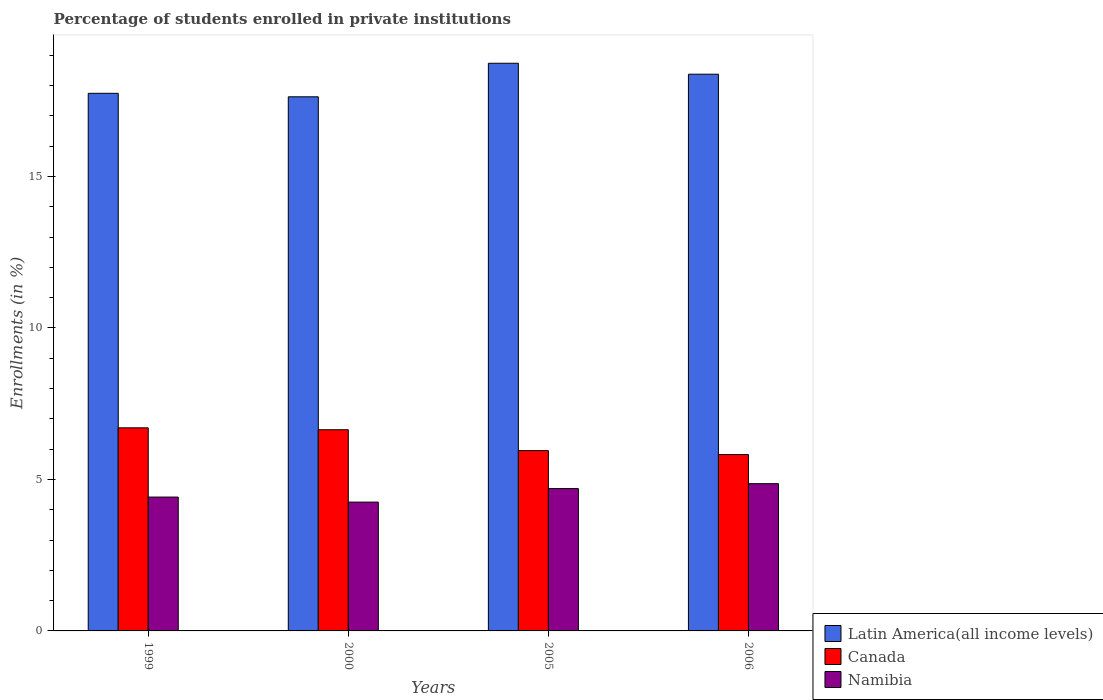How many groups of bars are there?
Give a very brief answer. 4. Are the number of bars per tick equal to the number of legend labels?
Give a very brief answer. Yes. How many bars are there on the 3rd tick from the right?
Provide a short and direct response. 3. What is the label of the 1st group of bars from the left?
Keep it short and to the point. 1999. What is the percentage of trained teachers in Canada in 1999?
Make the answer very short. 6.7. Across all years, what is the maximum percentage of trained teachers in Latin America(all income levels)?
Offer a very short reply. 18.73. Across all years, what is the minimum percentage of trained teachers in Namibia?
Provide a short and direct response. 4.25. What is the total percentage of trained teachers in Latin America(all income levels) in the graph?
Your response must be concise. 72.48. What is the difference between the percentage of trained teachers in Canada in 2000 and that in 2005?
Make the answer very short. 0.69. What is the difference between the percentage of trained teachers in Namibia in 2005 and the percentage of trained teachers in Latin America(all income levels) in 2006?
Provide a short and direct response. -13.68. What is the average percentage of trained teachers in Namibia per year?
Offer a terse response. 4.56. In the year 2000, what is the difference between the percentage of trained teachers in Namibia and percentage of trained teachers in Latin America(all income levels)?
Provide a succinct answer. -13.38. What is the ratio of the percentage of trained teachers in Canada in 1999 to that in 2006?
Keep it short and to the point. 1.15. Is the percentage of trained teachers in Latin America(all income levels) in 1999 less than that in 2006?
Your answer should be very brief. Yes. Is the difference between the percentage of trained teachers in Namibia in 1999 and 2000 greater than the difference between the percentage of trained teachers in Latin America(all income levels) in 1999 and 2000?
Your response must be concise. Yes. What is the difference between the highest and the second highest percentage of trained teachers in Canada?
Offer a very short reply. 0.06. What is the difference between the highest and the lowest percentage of trained teachers in Canada?
Your response must be concise. 0.88. In how many years, is the percentage of trained teachers in Namibia greater than the average percentage of trained teachers in Namibia taken over all years?
Keep it short and to the point. 2. What does the 3rd bar from the left in 2000 represents?
Provide a short and direct response. Namibia. What does the 3rd bar from the right in 2005 represents?
Your response must be concise. Latin America(all income levels). How many bars are there?
Provide a short and direct response. 12. Are all the bars in the graph horizontal?
Keep it short and to the point. No. What is the difference between two consecutive major ticks on the Y-axis?
Offer a very short reply. 5. Does the graph contain any zero values?
Your answer should be very brief. No. Does the graph contain grids?
Give a very brief answer. No. What is the title of the graph?
Your answer should be very brief. Percentage of students enrolled in private institutions. What is the label or title of the Y-axis?
Provide a succinct answer. Enrollments (in %). What is the Enrollments (in %) in Latin America(all income levels) in 1999?
Your answer should be compact. 17.74. What is the Enrollments (in %) in Canada in 1999?
Keep it short and to the point. 6.7. What is the Enrollments (in %) of Namibia in 1999?
Give a very brief answer. 4.42. What is the Enrollments (in %) in Latin America(all income levels) in 2000?
Provide a succinct answer. 17.63. What is the Enrollments (in %) in Canada in 2000?
Make the answer very short. 6.64. What is the Enrollments (in %) in Namibia in 2000?
Make the answer very short. 4.25. What is the Enrollments (in %) in Latin America(all income levels) in 2005?
Your answer should be compact. 18.73. What is the Enrollments (in %) of Canada in 2005?
Provide a succinct answer. 5.95. What is the Enrollments (in %) in Namibia in 2005?
Your response must be concise. 4.7. What is the Enrollments (in %) in Latin America(all income levels) in 2006?
Your response must be concise. 18.37. What is the Enrollments (in %) of Canada in 2006?
Ensure brevity in your answer.  5.82. What is the Enrollments (in %) in Namibia in 2006?
Provide a succinct answer. 4.86. Across all years, what is the maximum Enrollments (in %) of Latin America(all income levels)?
Keep it short and to the point. 18.73. Across all years, what is the maximum Enrollments (in %) of Canada?
Ensure brevity in your answer.  6.7. Across all years, what is the maximum Enrollments (in %) in Namibia?
Offer a terse response. 4.86. Across all years, what is the minimum Enrollments (in %) of Latin America(all income levels)?
Keep it short and to the point. 17.63. Across all years, what is the minimum Enrollments (in %) of Canada?
Ensure brevity in your answer.  5.82. Across all years, what is the minimum Enrollments (in %) in Namibia?
Keep it short and to the point. 4.25. What is the total Enrollments (in %) of Latin America(all income levels) in the graph?
Your answer should be very brief. 72.48. What is the total Enrollments (in %) in Canada in the graph?
Offer a terse response. 25.11. What is the total Enrollments (in %) of Namibia in the graph?
Offer a very short reply. 18.23. What is the difference between the Enrollments (in %) of Latin America(all income levels) in 1999 and that in 2000?
Make the answer very short. 0.11. What is the difference between the Enrollments (in %) in Canada in 1999 and that in 2000?
Provide a succinct answer. 0.06. What is the difference between the Enrollments (in %) in Namibia in 1999 and that in 2000?
Keep it short and to the point. 0.17. What is the difference between the Enrollments (in %) in Latin America(all income levels) in 1999 and that in 2005?
Your answer should be very brief. -0.99. What is the difference between the Enrollments (in %) in Canada in 1999 and that in 2005?
Offer a very short reply. 0.75. What is the difference between the Enrollments (in %) in Namibia in 1999 and that in 2005?
Give a very brief answer. -0.28. What is the difference between the Enrollments (in %) of Latin America(all income levels) in 1999 and that in 2006?
Offer a terse response. -0.63. What is the difference between the Enrollments (in %) of Canada in 1999 and that in 2006?
Offer a terse response. 0.88. What is the difference between the Enrollments (in %) in Namibia in 1999 and that in 2006?
Your answer should be very brief. -0.44. What is the difference between the Enrollments (in %) of Latin America(all income levels) in 2000 and that in 2005?
Keep it short and to the point. -1.11. What is the difference between the Enrollments (in %) of Canada in 2000 and that in 2005?
Your response must be concise. 0.69. What is the difference between the Enrollments (in %) in Namibia in 2000 and that in 2005?
Your answer should be very brief. -0.45. What is the difference between the Enrollments (in %) of Latin America(all income levels) in 2000 and that in 2006?
Provide a succinct answer. -0.75. What is the difference between the Enrollments (in %) of Canada in 2000 and that in 2006?
Your answer should be compact. 0.82. What is the difference between the Enrollments (in %) in Namibia in 2000 and that in 2006?
Ensure brevity in your answer.  -0.61. What is the difference between the Enrollments (in %) of Latin America(all income levels) in 2005 and that in 2006?
Offer a very short reply. 0.36. What is the difference between the Enrollments (in %) in Canada in 2005 and that in 2006?
Make the answer very short. 0.13. What is the difference between the Enrollments (in %) of Namibia in 2005 and that in 2006?
Your answer should be very brief. -0.16. What is the difference between the Enrollments (in %) of Latin America(all income levels) in 1999 and the Enrollments (in %) of Canada in 2000?
Your answer should be very brief. 11.1. What is the difference between the Enrollments (in %) of Latin America(all income levels) in 1999 and the Enrollments (in %) of Namibia in 2000?
Provide a short and direct response. 13.49. What is the difference between the Enrollments (in %) in Canada in 1999 and the Enrollments (in %) in Namibia in 2000?
Offer a very short reply. 2.45. What is the difference between the Enrollments (in %) of Latin America(all income levels) in 1999 and the Enrollments (in %) of Canada in 2005?
Provide a short and direct response. 11.79. What is the difference between the Enrollments (in %) in Latin America(all income levels) in 1999 and the Enrollments (in %) in Namibia in 2005?
Ensure brevity in your answer.  13.04. What is the difference between the Enrollments (in %) of Canada in 1999 and the Enrollments (in %) of Namibia in 2005?
Provide a short and direct response. 2. What is the difference between the Enrollments (in %) in Latin America(all income levels) in 1999 and the Enrollments (in %) in Canada in 2006?
Ensure brevity in your answer.  11.92. What is the difference between the Enrollments (in %) of Latin America(all income levels) in 1999 and the Enrollments (in %) of Namibia in 2006?
Ensure brevity in your answer.  12.88. What is the difference between the Enrollments (in %) in Canada in 1999 and the Enrollments (in %) in Namibia in 2006?
Offer a very short reply. 1.84. What is the difference between the Enrollments (in %) of Latin America(all income levels) in 2000 and the Enrollments (in %) of Canada in 2005?
Keep it short and to the point. 11.68. What is the difference between the Enrollments (in %) of Latin America(all income levels) in 2000 and the Enrollments (in %) of Namibia in 2005?
Your response must be concise. 12.93. What is the difference between the Enrollments (in %) in Canada in 2000 and the Enrollments (in %) in Namibia in 2005?
Offer a terse response. 1.94. What is the difference between the Enrollments (in %) of Latin America(all income levels) in 2000 and the Enrollments (in %) of Canada in 2006?
Keep it short and to the point. 11.81. What is the difference between the Enrollments (in %) of Latin America(all income levels) in 2000 and the Enrollments (in %) of Namibia in 2006?
Make the answer very short. 12.77. What is the difference between the Enrollments (in %) of Canada in 2000 and the Enrollments (in %) of Namibia in 2006?
Ensure brevity in your answer.  1.78. What is the difference between the Enrollments (in %) in Latin America(all income levels) in 2005 and the Enrollments (in %) in Canada in 2006?
Your response must be concise. 12.91. What is the difference between the Enrollments (in %) of Latin America(all income levels) in 2005 and the Enrollments (in %) of Namibia in 2006?
Provide a succinct answer. 13.88. What is the difference between the Enrollments (in %) in Canada in 2005 and the Enrollments (in %) in Namibia in 2006?
Your answer should be compact. 1.09. What is the average Enrollments (in %) of Latin America(all income levels) per year?
Keep it short and to the point. 18.12. What is the average Enrollments (in %) in Canada per year?
Provide a short and direct response. 6.28. What is the average Enrollments (in %) of Namibia per year?
Give a very brief answer. 4.56. In the year 1999, what is the difference between the Enrollments (in %) of Latin America(all income levels) and Enrollments (in %) of Canada?
Your answer should be compact. 11.04. In the year 1999, what is the difference between the Enrollments (in %) of Latin America(all income levels) and Enrollments (in %) of Namibia?
Offer a very short reply. 13.32. In the year 1999, what is the difference between the Enrollments (in %) of Canada and Enrollments (in %) of Namibia?
Make the answer very short. 2.29. In the year 2000, what is the difference between the Enrollments (in %) of Latin America(all income levels) and Enrollments (in %) of Canada?
Your answer should be compact. 10.99. In the year 2000, what is the difference between the Enrollments (in %) of Latin America(all income levels) and Enrollments (in %) of Namibia?
Provide a short and direct response. 13.38. In the year 2000, what is the difference between the Enrollments (in %) of Canada and Enrollments (in %) of Namibia?
Your answer should be very brief. 2.39. In the year 2005, what is the difference between the Enrollments (in %) in Latin America(all income levels) and Enrollments (in %) in Canada?
Your answer should be compact. 12.78. In the year 2005, what is the difference between the Enrollments (in %) of Latin America(all income levels) and Enrollments (in %) of Namibia?
Provide a succinct answer. 14.04. In the year 2005, what is the difference between the Enrollments (in %) of Canada and Enrollments (in %) of Namibia?
Offer a terse response. 1.25. In the year 2006, what is the difference between the Enrollments (in %) in Latin America(all income levels) and Enrollments (in %) in Canada?
Offer a terse response. 12.55. In the year 2006, what is the difference between the Enrollments (in %) in Latin America(all income levels) and Enrollments (in %) in Namibia?
Provide a succinct answer. 13.51. In the year 2006, what is the difference between the Enrollments (in %) of Canada and Enrollments (in %) of Namibia?
Keep it short and to the point. 0.96. What is the ratio of the Enrollments (in %) in Canada in 1999 to that in 2000?
Offer a very short reply. 1.01. What is the ratio of the Enrollments (in %) of Namibia in 1999 to that in 2000?
Offer a terse response. 1.04. What is the ratio of the Enrollments (in %) of Latin America(all income levels) in 1999 to that in 2005?
Provide a succinct answer. 0.95. What is the ratio of the Enrollments (in %) in Canada in 1999 to that in 2005?
Provide a short and direct response. 1.13. What is the ratio of the Enrollments (in %) in Namibia in 1999 to that in 2005?
Offer a very short reply. 0.94. What is the ratio of the Enrollments (in %) of Latin America(all income levels) in 1999 to that in 2006?
Your answer should be compact. 0.97. What is the ratio of the Enrollments (in %) in Canada in 1999 to that in 2006?
Ensure brevity in your answer.  1.15. What is the ratio of the Enrollments (in %) in Namibia in 1999 to that in 2006?
Your response must be concise. 0.91. What is the ratio of the Enrollments (in %) of Latin America(all income levels) in 2000 to that in 2005?
Your answer should be compact. 0.94. What is the ratio of the Enrollments (in %) of Canada in 2000 to that in 2005?
Keep it short and to the point. 1.12. What is the ratio of the Enrollments (in %) of Namibia in 2000 to that in 2005?
Keep it short and to the point. 0.9. What is the ratio of the Enrollments (in %) in Latin America(all income levels) in 2000 to that in 2006?
Ensure brevity in your answer.  0.96. What is the ratio of the Enrollments (in %) in Canada in 2000 to that in 2006?
Offer a very short reply. 1.14. What is the ratio of the Enrollments (in %) in Namibia in 2000 to that in 2006?
Your answer should be very brief. 0.87. What is the ratio of the Enrollments (in %) in Latin America(all income levels) in 2005 to that in 2006?
Keep it short and to the point. 1.02. What is the ratio of the Enrollments (in %) in Canada in 2005 to that in 2006?
Keep it short and to the point. 1.02. What is the ratio of the Enrollments (in %) in Namibia in 2005 to that in 2006?
Your response must be concise. 0.97. What is the difference between the highest and the second highest Enrollments (in %) in Latin America(all income levels)?
Offer a very short reply. 0.36. What is the difference between the highest and the second highest Enrollments (in %) in Canada?
Your response must be concise. 0.06. What is the difference between the highest and the second highest Enrollments (in %) of Namibia?
Offer a very short reply. 0.16. What is the difference between the highest and the lowest Enrollments (in %) in Latin America(all income levels)?
Make the answer very short. 1.11. What is the difference between the highest and the lowest Enrollments (in %) of Canada?
Make the answer very short. 0.88. What is the difference between the highest and the lowest Enrollments (in %) in Namibia?
Give a very brief answer. 0.61. 